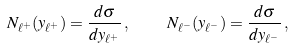<formula> <loc_0><loc_0><loc_500><loc_500>N _ { \ell ^ { + } } ( y _ { \ell ^ { + } } ) = \frac { d \sigma } { d y _ { \ell ^ { + } } } \, , \quad N _ { \ell ^ { - } } ( y _ { \ell ^ { - } } ) = \frac { d \sigma } { d y _ { \ell ^ { - } } } \, ,</formula> 